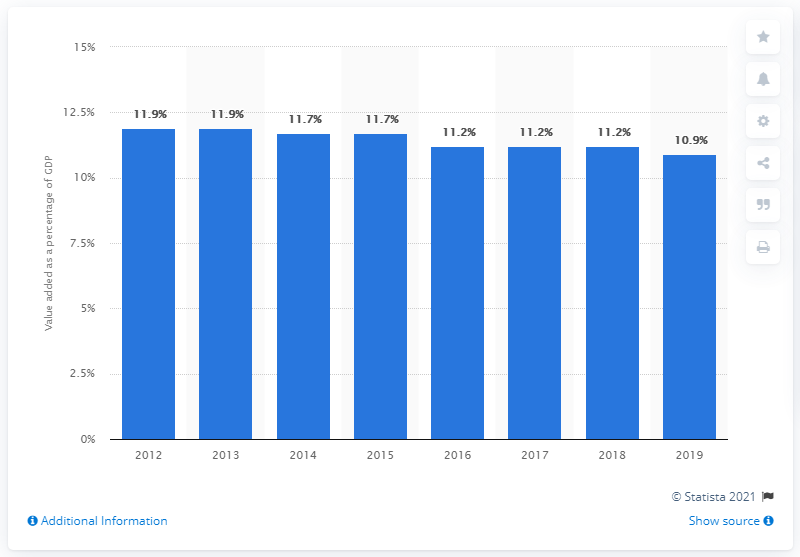Draw attention to some important aspects in this diagram. In 2019, the manufacturing sector accounted for 10.9% of the nation's Gross Domestic Product. 